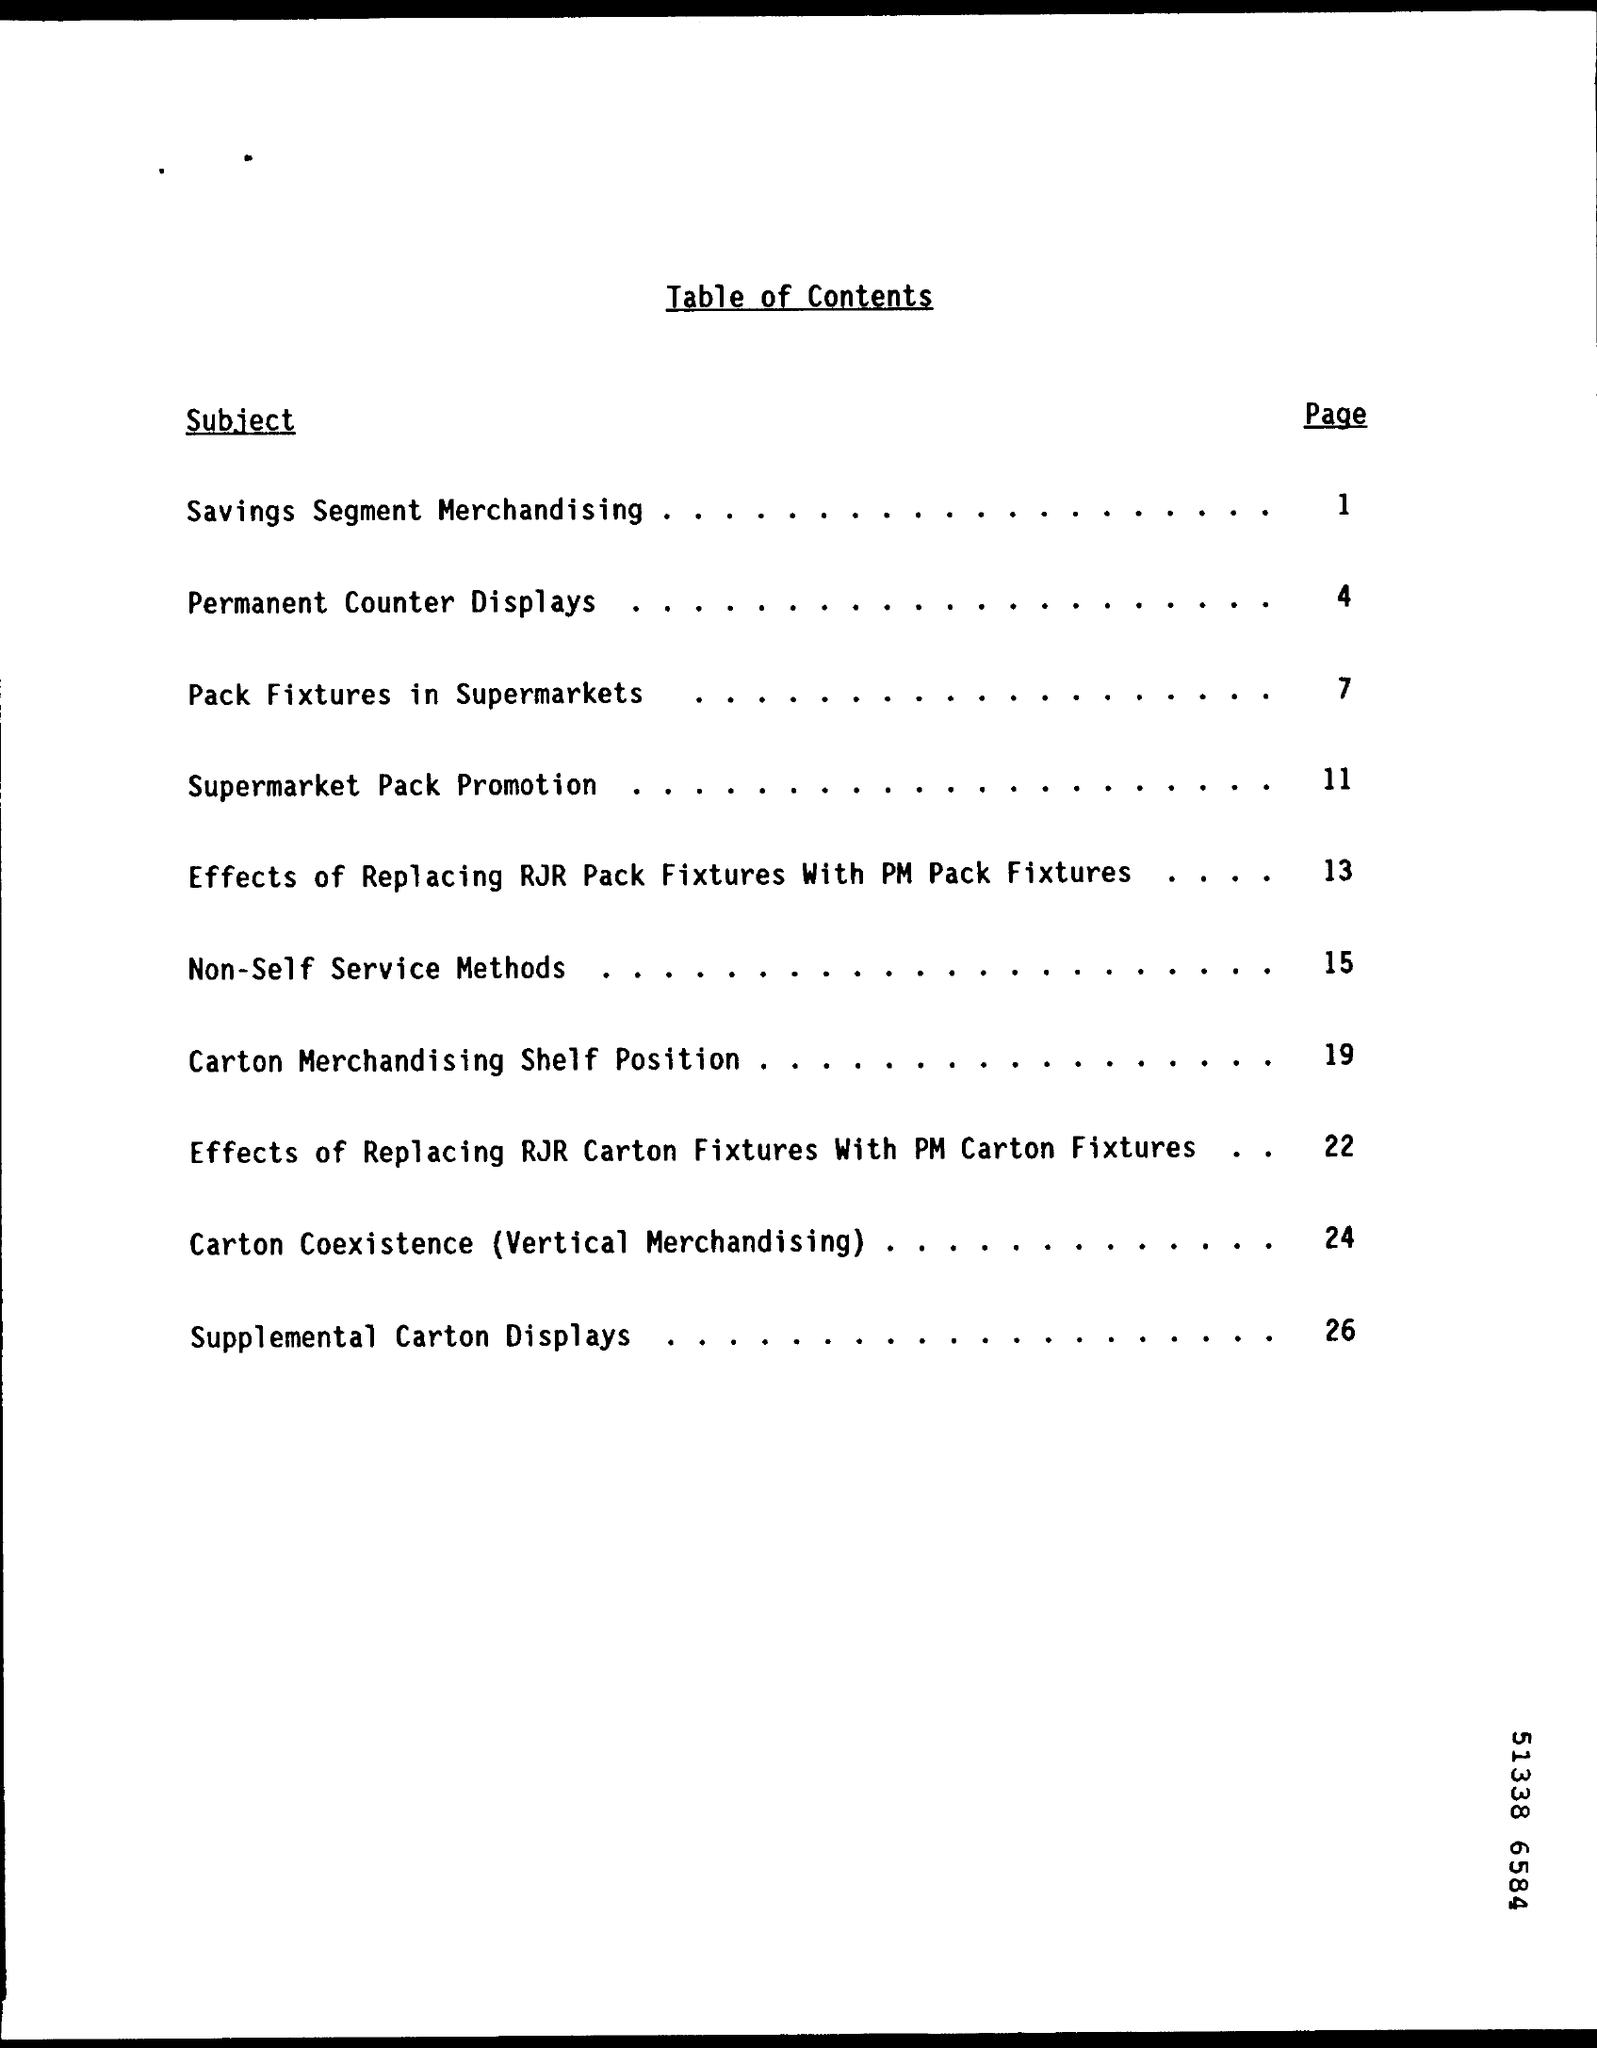Indicate a few pertinent items in this graphic. The subject of "Permanent Counter Displays" can be found on page number 4.. The page number for the subject 'Savings Segment Merchandising' is 1. The title of the document is [insert title here], and it includes a table of contents. 